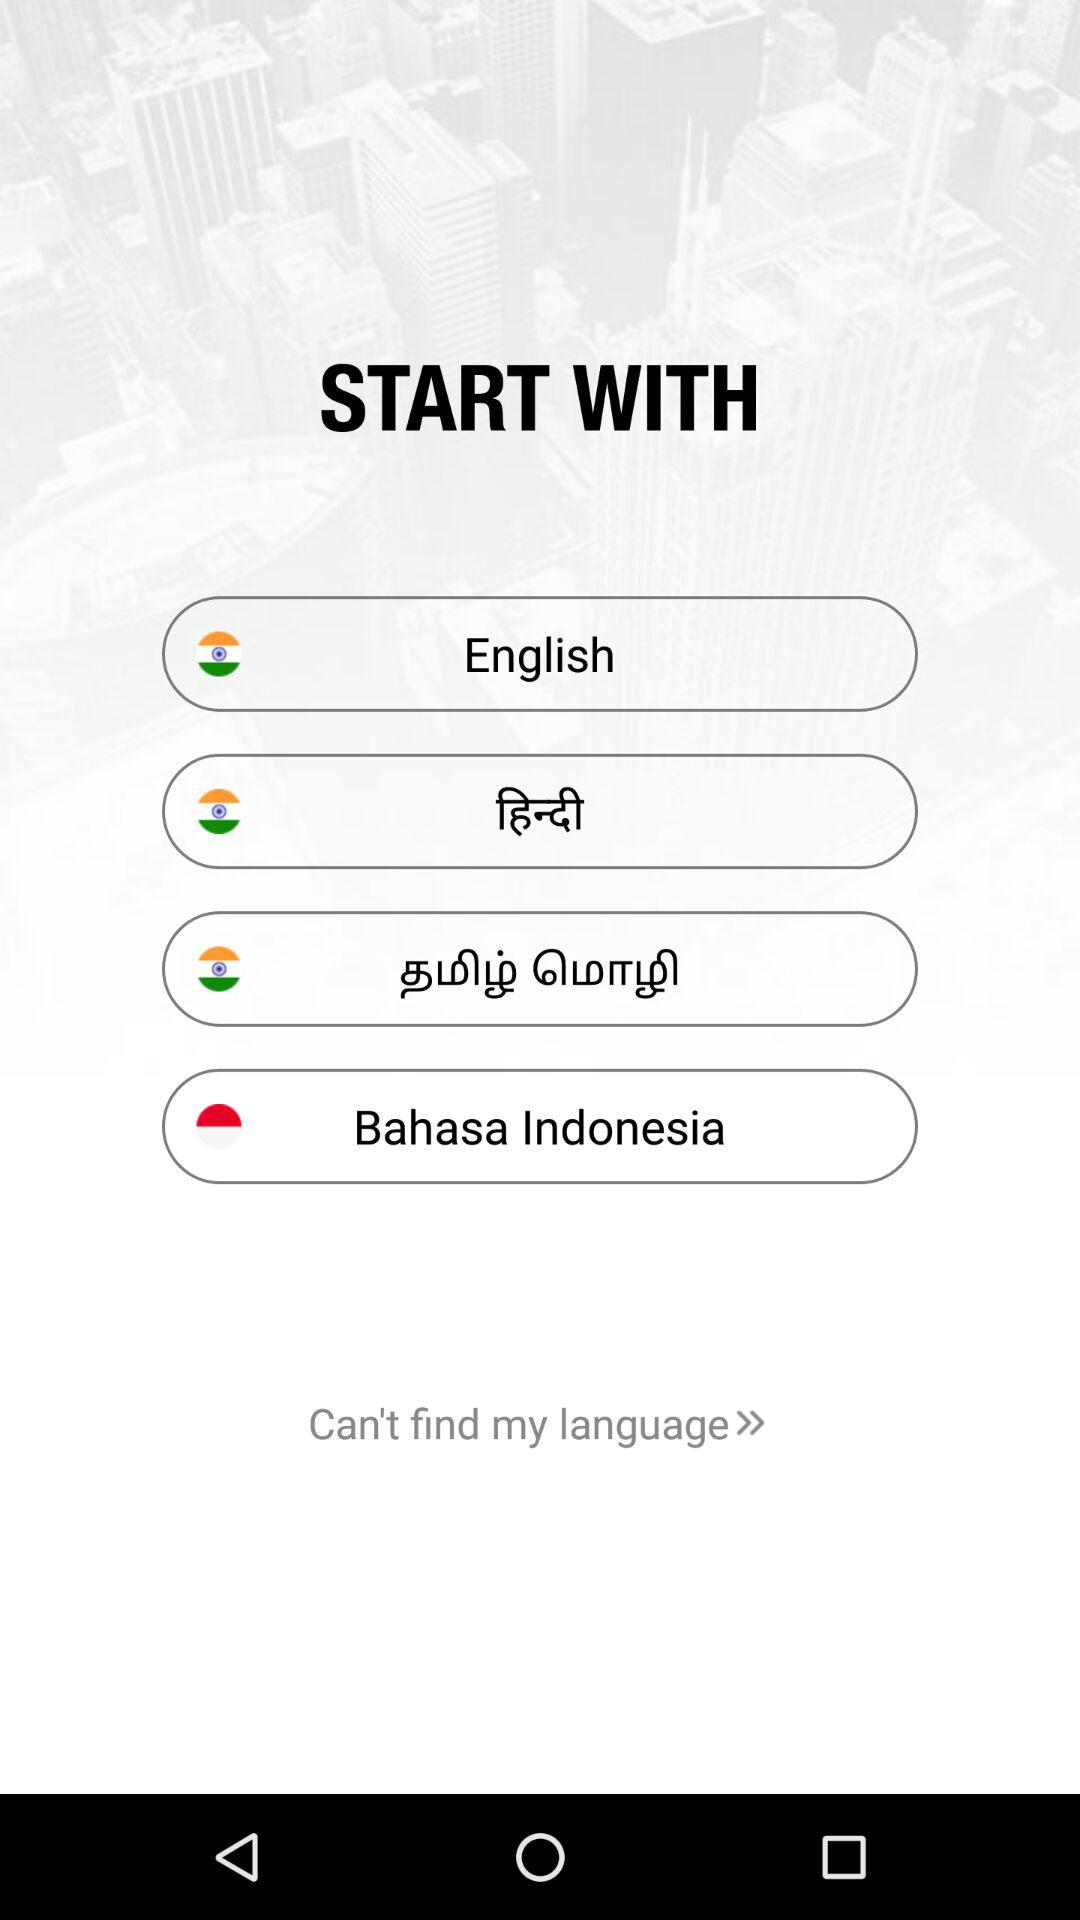How many languages are available to select in this language selection screen?
Answer the question using a single word or phrase. 4 